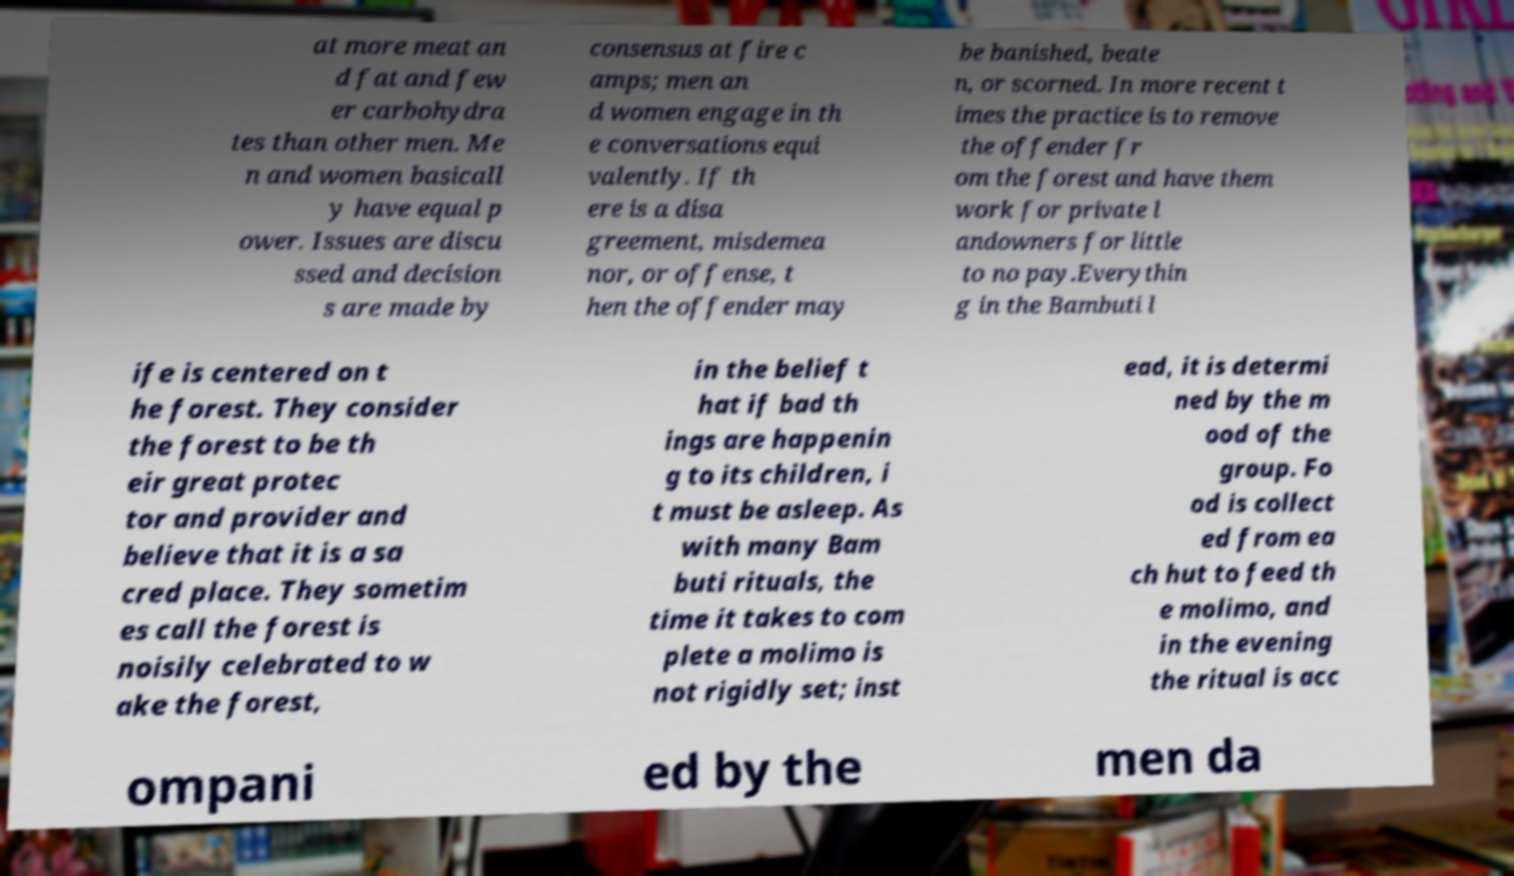Please identify and transcribe the text found in this image. at more meat an d fat and few er carbohydra tes than other men. Me n and women basicall y have equal p ower. Issues are discu ssed and decision s are made by consensus at fire c amps; men an d women engage in th e conversations equi valently. If th ere is a disa greement, misdemea nor, or offense, t hen the offender may be banished, beate n, or scorned. In more recent t imes the practice is to remove the offender fr om the forest and have them work for private l andowners for little to no pay.Everythin g in the Bambuti l ife is centered on t he forest. They consider the forest to be th eir great protec tor and provider and believe that it is a sa cred place. They sometim es call the forest is noisily celebrated to w ake the forest, in the belief t hat if bad th ings are happenin g to its children, i t must be asleep. As with many Bam buti rituals, the time it takes to com plete a molimo is not rigidly set; inst ead, it is determi ned by the m ood of the group. Fo od is collect ed from ea ch hut to feed th e molimo, and in the evening the ritual is acc ompani ed by the men da 